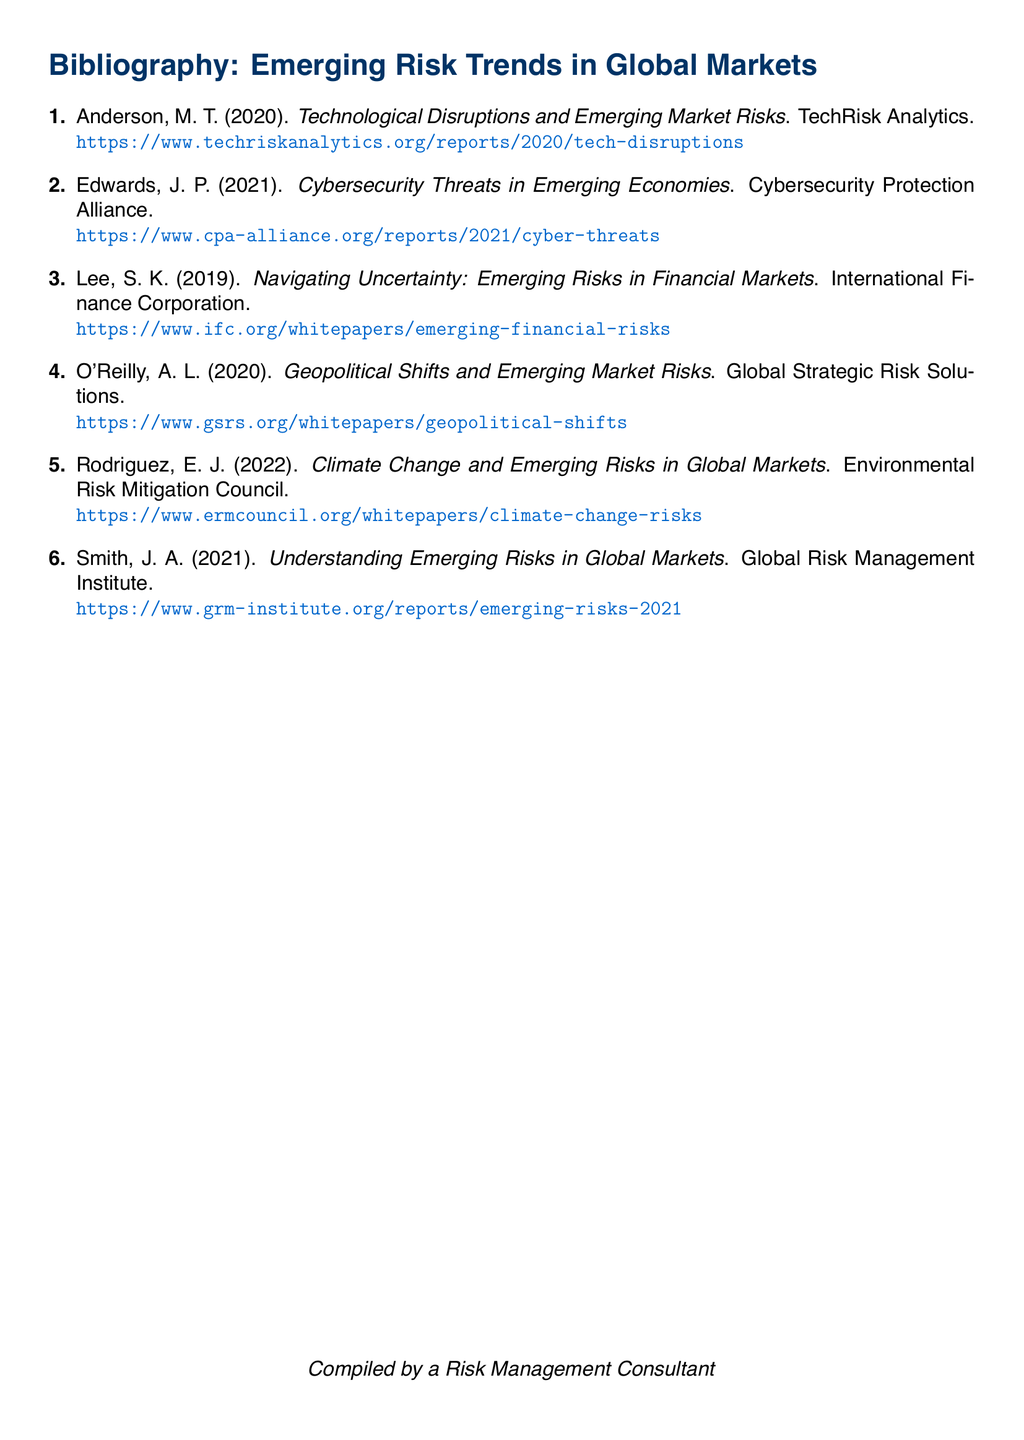What is the title of the report by M. T. Anderson? The title of the report by M. T. Anderson is "Technological Disruptions and Emerging Market Risks."
Answer: Technological Disruptions and Emerging Market Risks Who authored the 2021 report on cybersecurity threats? The author of the 2021 report on cybersecurity threats is J. P. Edwards.
Answer: J. P. Edwards What organization published the whitepaper on climate change risks? The whitepaper on climate change risks was published by the Environmental Risk Mitigation Council.
Answer: Environmental Risk Mitigation Council When was the report titled "Understanding Emerging Risks in Global Markets" published? The report titled "Understanding Emerging Risks in Global Markets" was published in 2021.
Answer: 2021 Which report discusses geopolitical shifts and emerging market risks? The report that discusses geopolitical shifts and emerging market risks is authored by A. L. O'Reilly.
Answer: A. L. O'Reilly How many reports are listed in this bibliography? There are six reports listed in this bibliography.
Answer: 6 What is the common theme among the reports in this bibliography? The common theme among the reports in this bibliography is emerging risk trends in global markets.
Answer: Emerging risk trends in global markets According to the document, what is the last name of the author of the report on financial markets? The last name of the author of the report on financial markets is Lee.
Answer: Lee What organization is associated with the report on technology disruptions? The organization associated with the report on technology disruptions is TechRisk Analytics.
Answer: TechRisk Analytics 